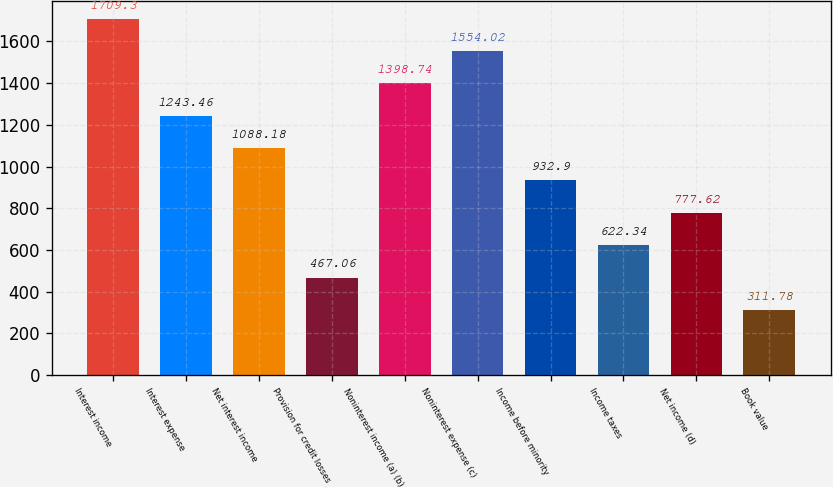Convert chart. <chart><loc_0><loc_0><loc_500><loc_500><bar_chart><fcel>Interest income<fcel>Interest expense<fcel>Net interest income<fcel>Provision for credit losses<fcel>Noninterest income (a) (b)<fcel>Noninterest expense (c)<fcel>Income before minority<fcel>Income taxes<fcel>Net income (d)<fcel>Book value<nl><fcel>1709.3<fcel>1243.46<fcel>1088.18<fcel>467.06<fcel>1398.74<fcel>1554.02<fcel>932.9<fcel>622.34<fcel>777.62<fcel>311.78<nl></chart> 